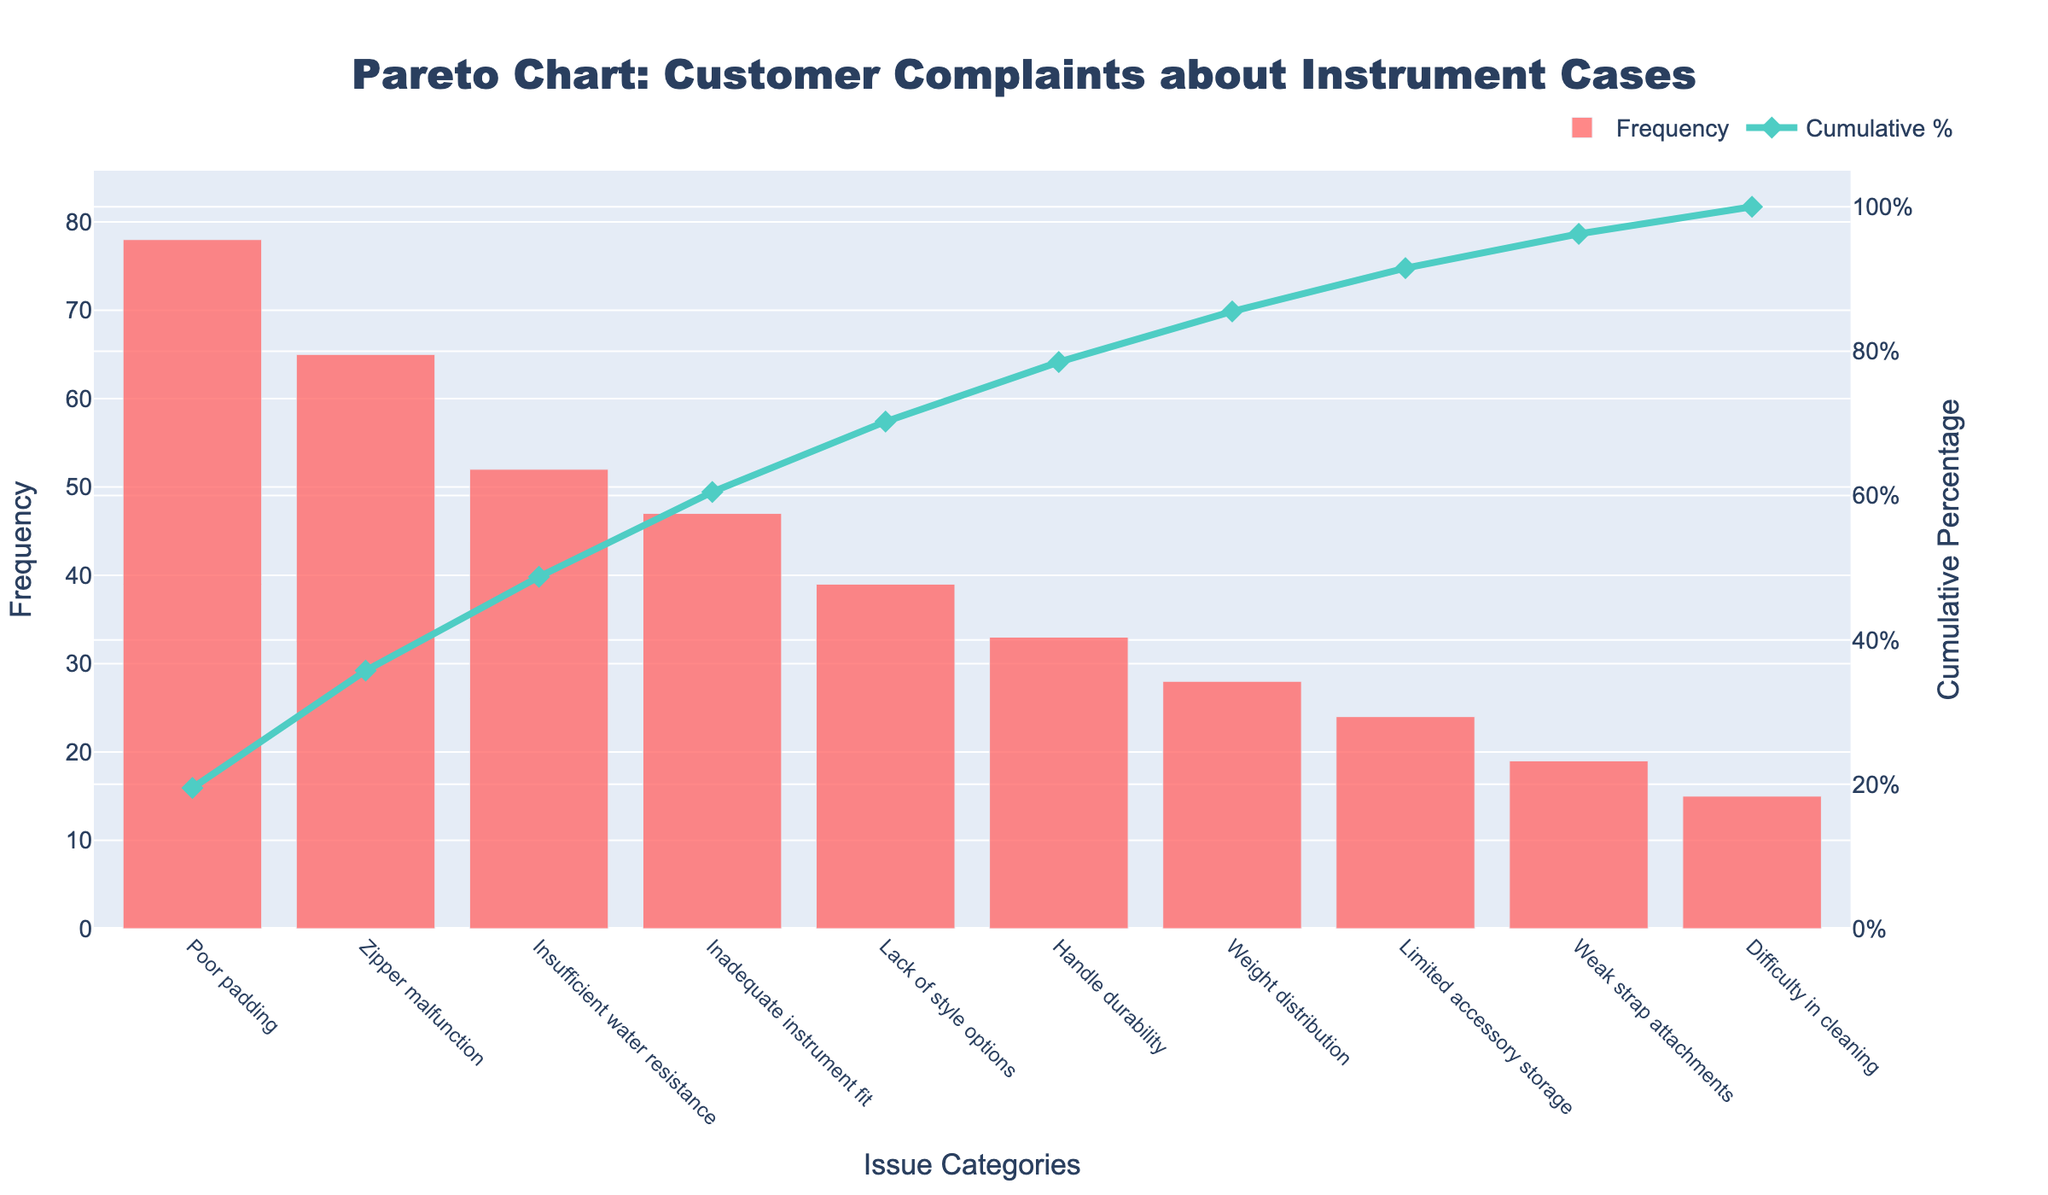What's the title of the figure? The title is usually the most prominent text at the top of the chart, designed to give a summary of the chart's content. In this case, the title is "Pareto Chart: Customer Complaints about Instrument Cases".
Answer: Pareto Chart: Customer Complaints about Instrument Cases Which issue had the highest frequency of complaints? The issue with the highest frequency will have the tallest bar in the bar chart. Here, the tallest bar is for "Poor padding" which has a frequency of 78.
Answer: Poor padding What is the cumulative percentage after including the complaints about "Inadequate instrument fit"? To find this, locate the cumulative percentage line marker above "Inadequate instrument fit". The line marker shows a cumulative percentage of around 80%.
Answer: About 80% How many issues had a frequency of complaints higher than 50? To determine this, identify the bars in the chart with heights above the 50 mark on the frequency axis. "Poor padding", "Zipper malfunction", and "Insufficient water resistance" are the only issues with frequencies higher than 50.
Answer: 3 What is the color of the bar representing the frequency of complaints? The color of the bars representing frequency can be deduced by examining the color used for the bars in the figure. They are colored in a shade of red (#FF6B6B).
Answer: Red What's the approximate cumulative percentage after the first three issue categories? To calculate this, sum the cumulative percentages for the first three categories: "Poor padding" (31.8%), "Zipper malfunction" (58.3%), and "Insufficient water resistance" (79.5%). The approximate cumulative percentage is close to 79.5%.
Answer: About 79.5% Which issue category's cumulative percentage just exceeds the 100% mark? To find this, look at the cumulative percentage line that first goes beyond the 100% mark. This happens right after "Difficulty in cleaning". However, the cumulative percentage does not actually exceed 100% in this chart; it terminates at exactly 100%.
Answer: Does not exceed By how much does the frequency of "Handle durability" complaints exceed "Limited accessory storage"? Identify the heights of the bars for these categories. "Handle durability" has a frequency of 33, and "Limited accessory storage" has a frequency of 24. Subtracting the latter from the former gives 33 - 24 = 9.
Answer: 9 What is the range of the cumulative percentage axis? The range can be seen on the right vertical axis, indicating the cumulative percentage. It ranges from 0% at the bottom to 105% at the top.
Answer: 0% to 105% 